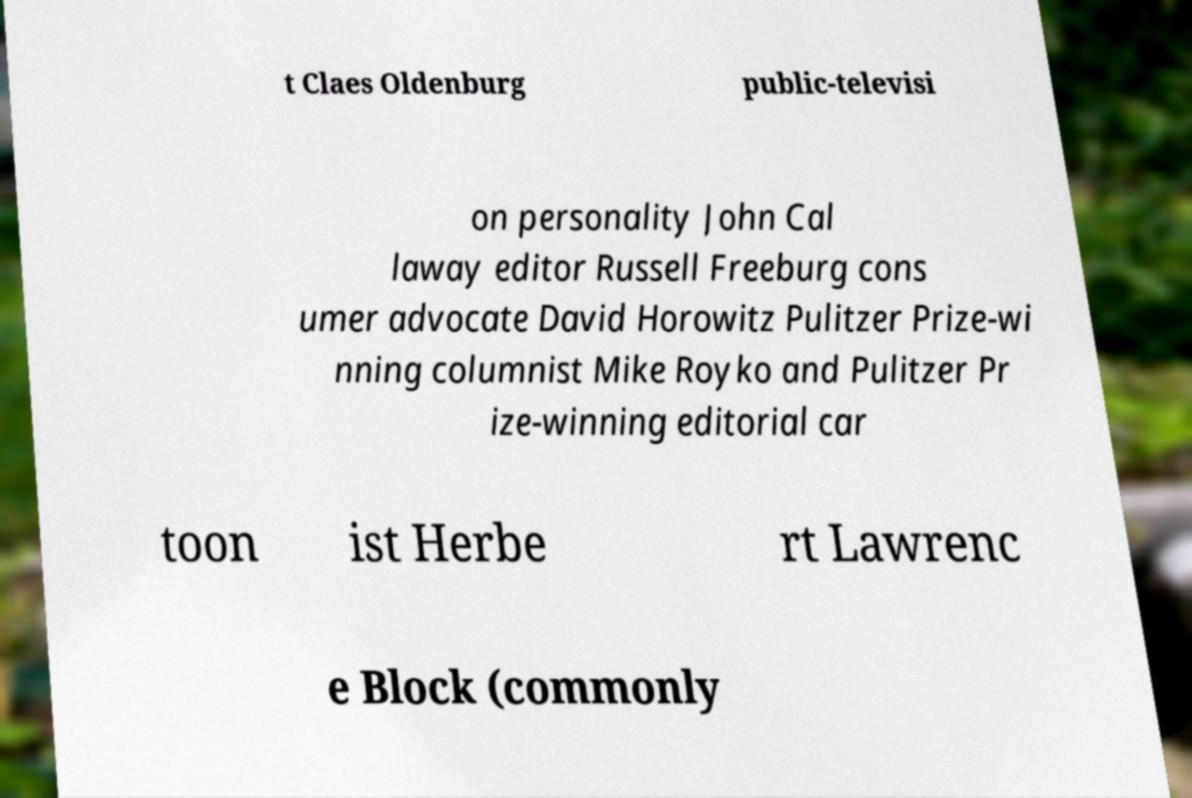I need the written content from this picture converted into text. Can you do that? t Claes Oldenburg public-televisi on personality John Cal laway editor Russell Freeburg cons umer advocate David Horowitz Pulitzer Prize-wi nning columnist Mike Royko and Pulitzer Pr ize-winning editorial car toon ist Herbe rt Lawrenc e Block (commonly 